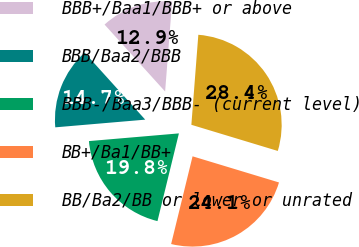Convert chart to OTSL. <chart><loc_0><loc_0><loc_500><loc_500><pie_chart><fcel>BBB+/Baa1/BBB+ or above<fcel>BBB/Baa2/BBB<fcel>BBB-/Baa3/BBB- (current level)<fcel>BB+/Ba1/BB+<fcel>BB/Ba2/BB or lower or unrated<nl><fcel>12.93%<fcel>14.66%<fcel>19.83%<fcel>24.14%<fcel>28.45%<nl></chart> 